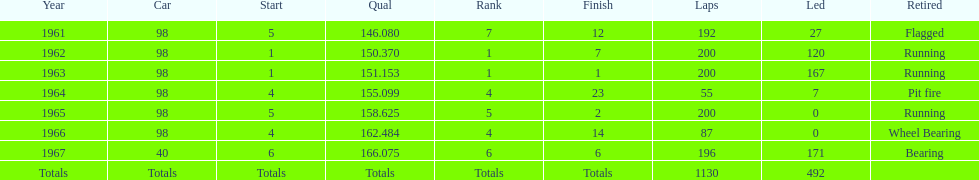In which years did he lead the race the least? 1965, 1966. 